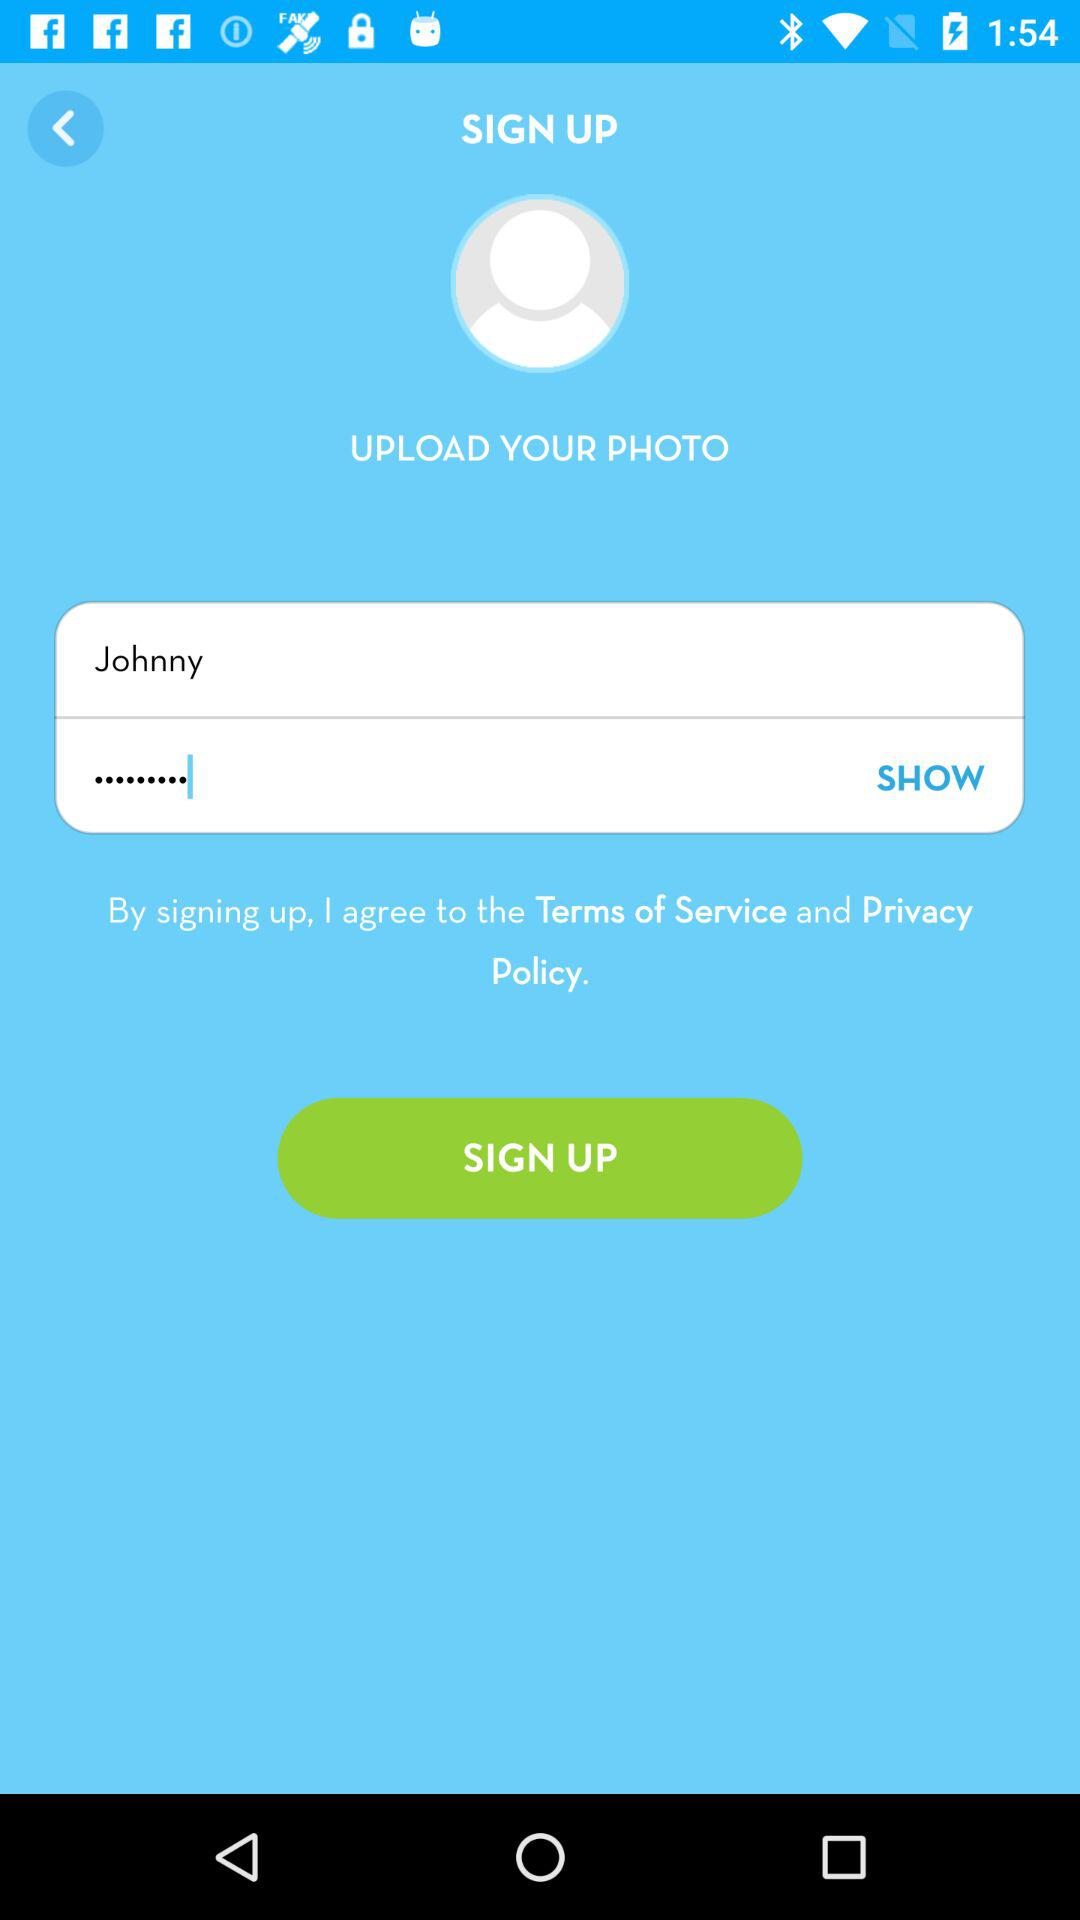What is the name of the user? The name of the user is Johnny. 